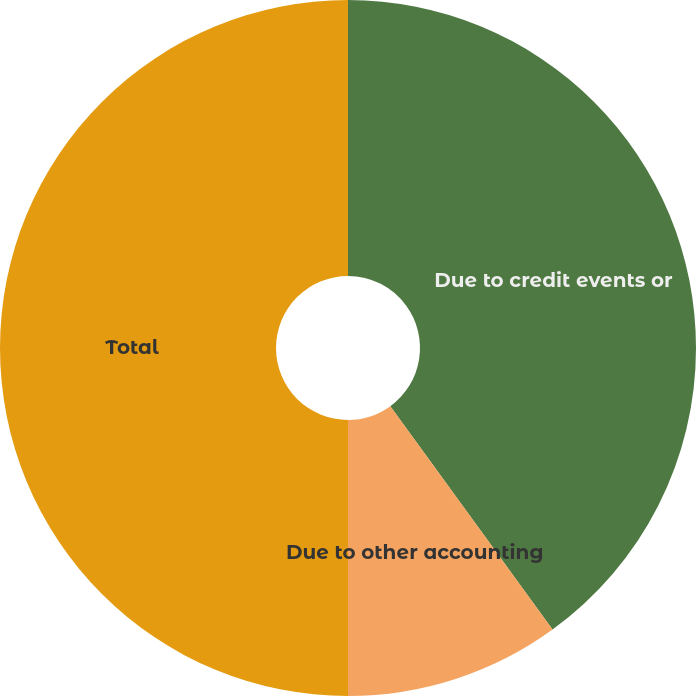Convert chart to OTSL. <chart><loc_0><loc_0><loc_500><loc_500><pie_chart><fcel>Due to credit events or<fcel>Due to other accounting<fcel>Total<nl><fcel>40.0%<fcel>10.0%<fcel>50.0%<nl></chart> 